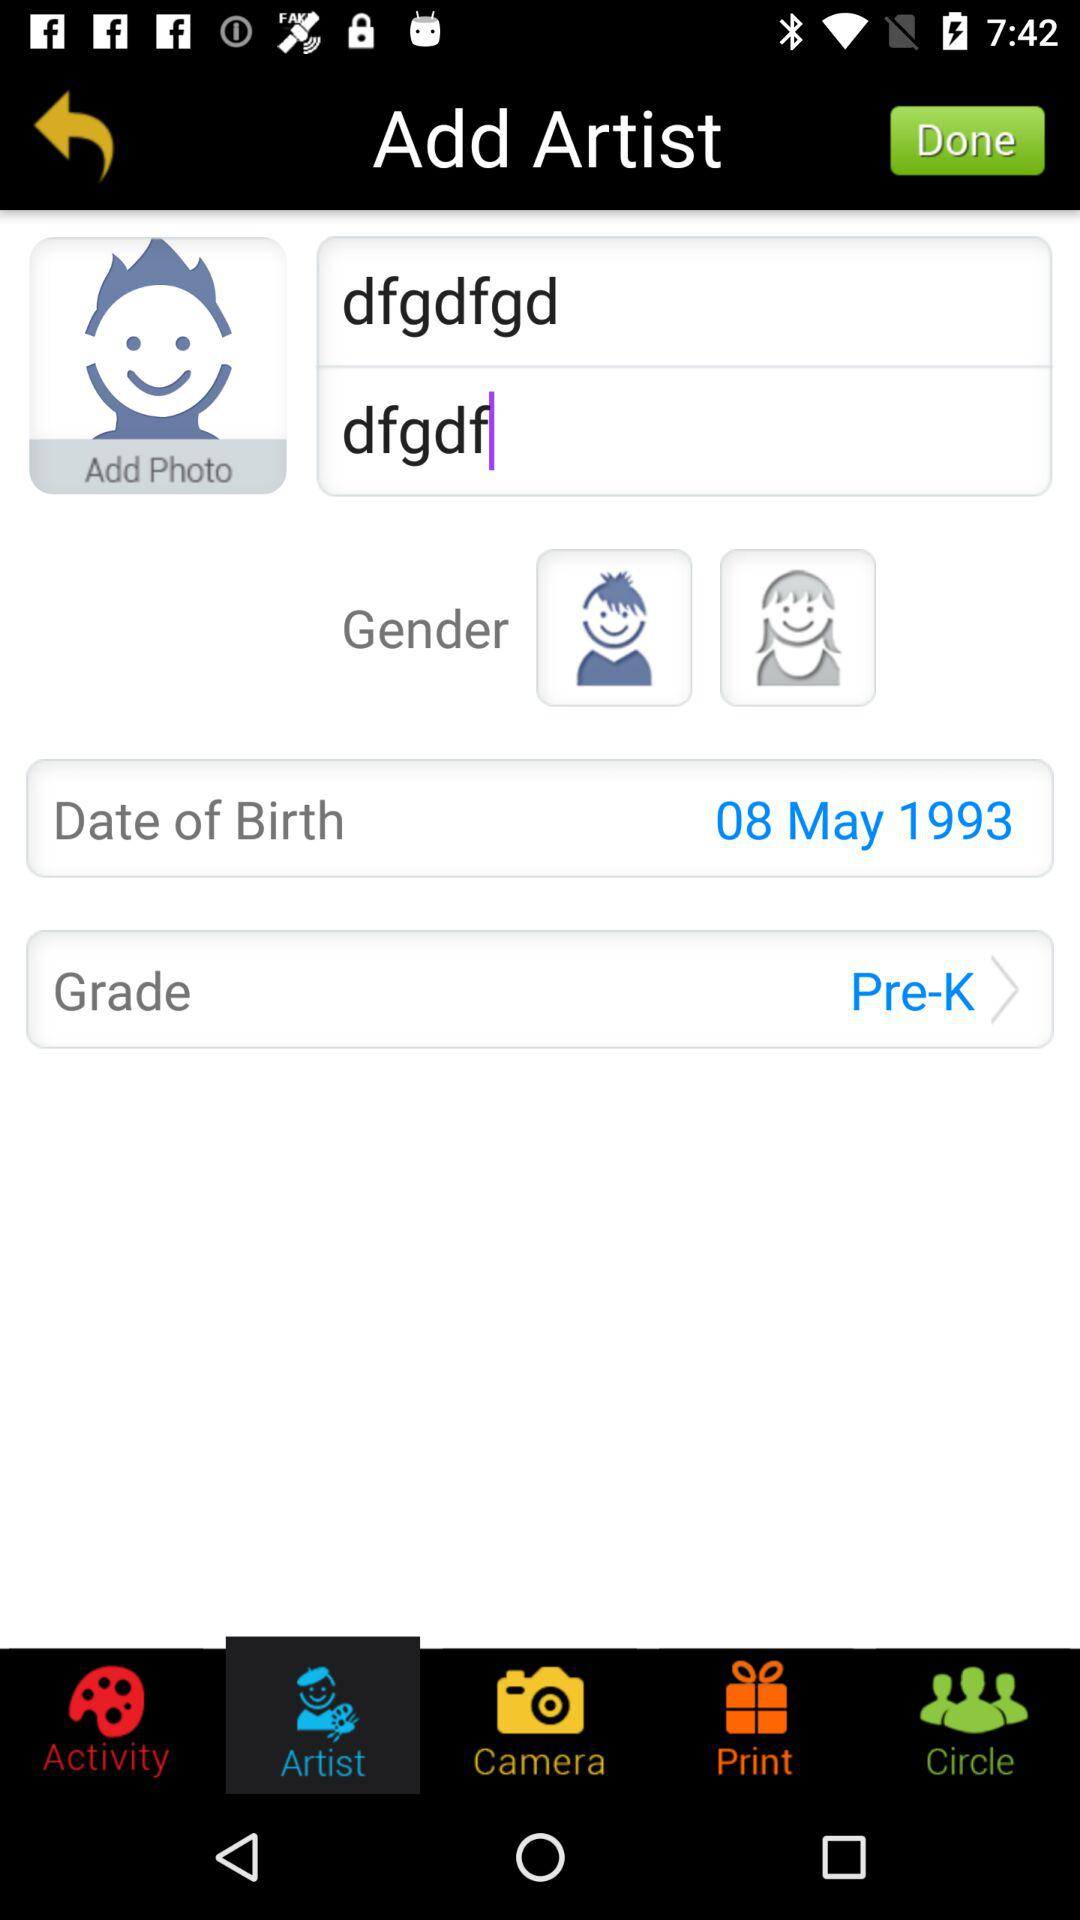What is the grade? The grade is "Pre-K". 